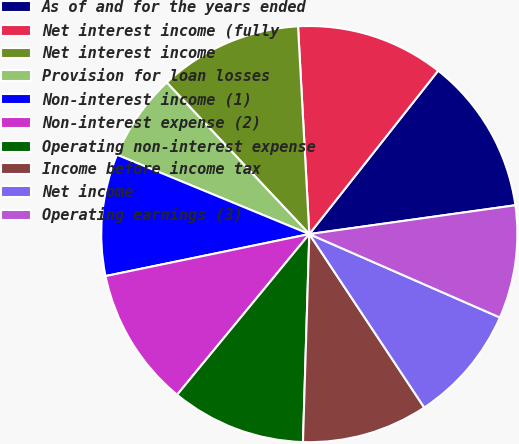Convert chart. <chart><loc_0><loc_0><loc_500><loc_500><pie_chart><fcel>As of and for the years ended<fcel>Net interest income (fully<fcel>Net interest income<fcel>Provision for loan losses<fcel>Non-interest income (1)<fcel>Non-interest expense (2)<fcel>Operating non-interest expense<fcel>Income before income tax<fcel>Net income<fcel>Operating earnings (3)<nl><fcel>12.16%<fcel>11.49%<fcel>11.15%<fcel>6.76%<fcel>9.46%<fcel>10.81%<fcel>10.47%<fcel>9.8%<fcel>9.12%<fcel>8.78%<nl></chart> 